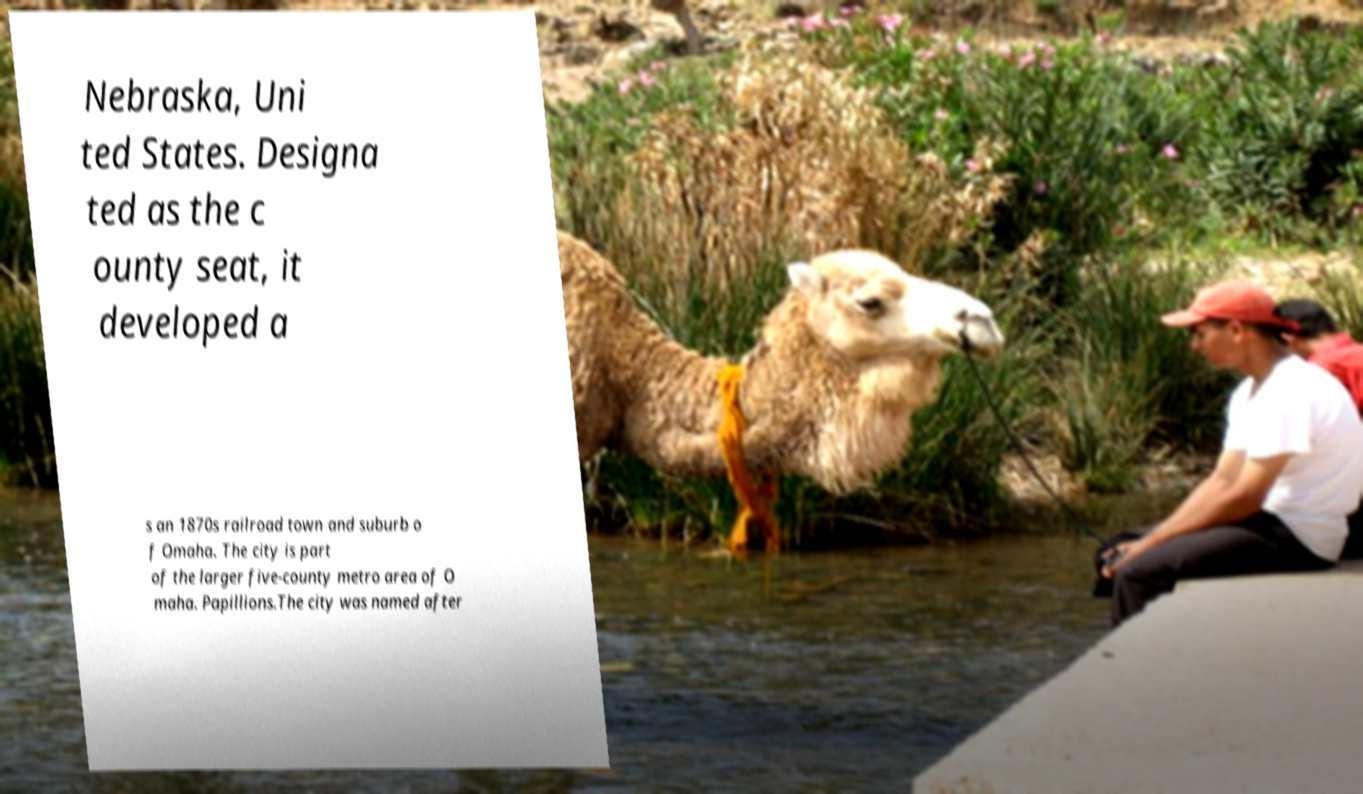Please read and relay the text visible in this image. What does it say? Nebraska, Uni ted States. Designa ted as the c ounty seat, it developed a s an 1870s railroad town and suburb o f Omaha. The city is part of the larger five-county metro area of O maha. Papillions.The city was named after 